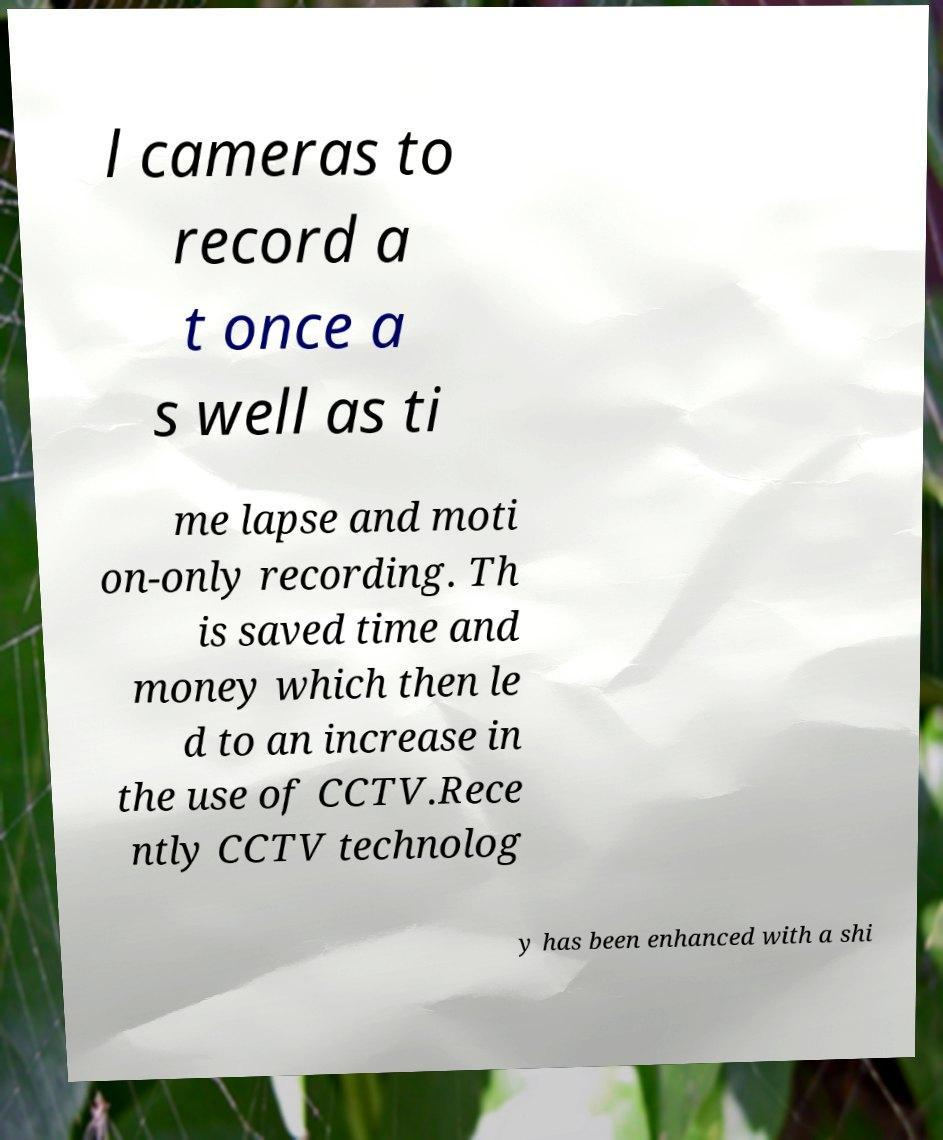Can you read and provide the text displayed in the image?This photo seems to have some interesting text. Can you extract and type it out for me? l cameras to record a t once a s well as ti me lapse and moti on-only recording. Th is saved time and money which then le d to an increase in the use of CCTV.Rece ntly CCTV technolog y has been enhanced with a shi 